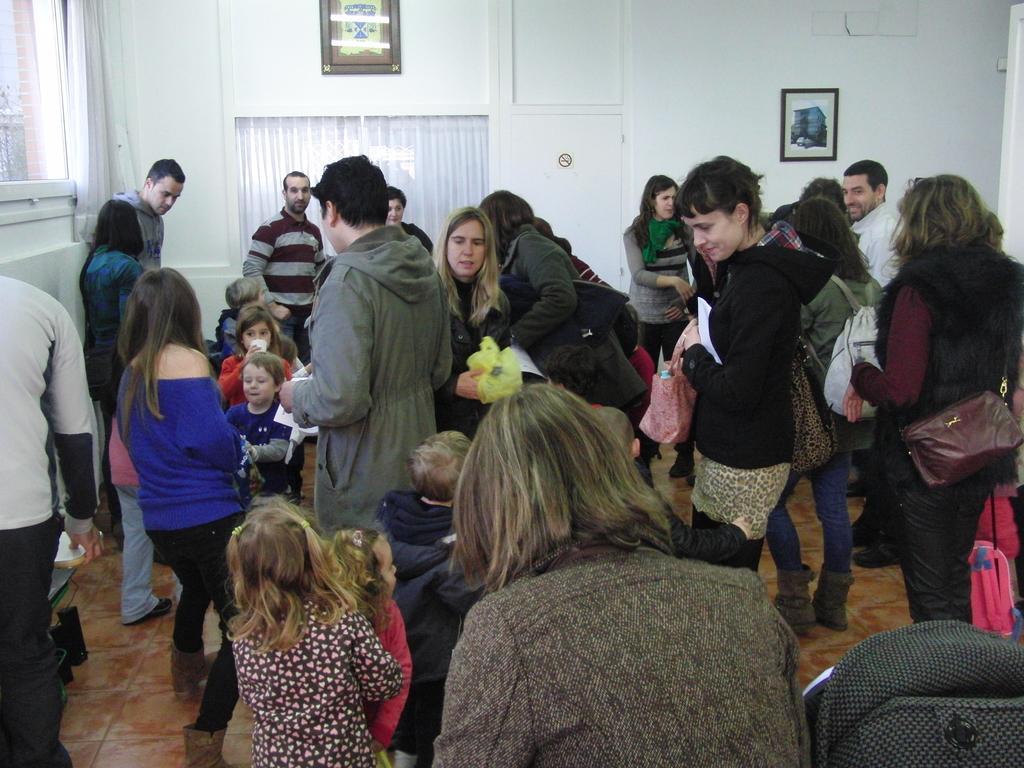Please provide a concise description of this image. There are men, women and children in this room. In the back there's a wall with curtains and photo frames. 